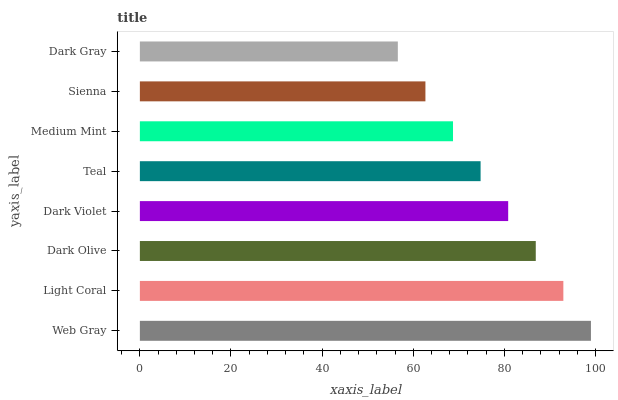Is Dark Gray the minimum?
Answer yes or no. Yes. Is Web Gray the maximum?
Answer yes or no. Yes. Is Light Coral the minimum?
Answer yes or no. No. Is Light Coral the maximum?
Answer yes or no. No. Is Web Gray greater than Light Coral?
Answer yes or no. Yes. Is Light Coral less than Web Gray?
Answer yes or no. Yes. Is Light Coral greater than Web Gray?
Answer yes or no. No. Is Web Gray less than Light Coral?
Answer yes or no. No. Is Dark Violet the high median?
Answer yes or no. Yes. Is Teal the low median?
Answer yes or no. Yes. Is Teal the high median?
Answer yes or no. No. Is Dark Olive the low median?
Answer yes or no. No. 